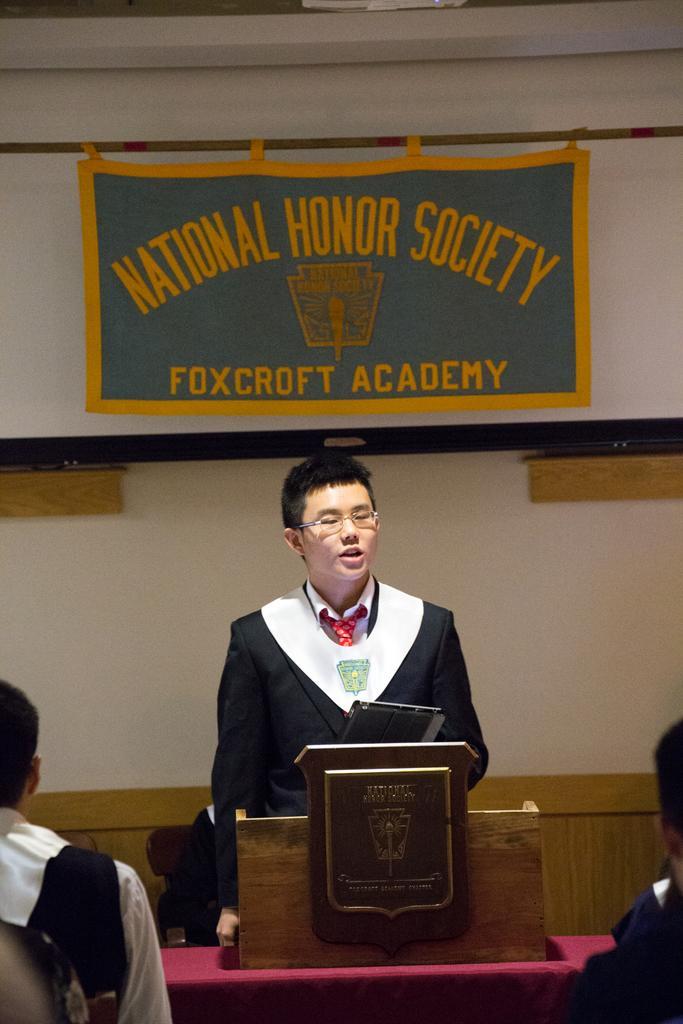Describe this image in one or two sentences. In the center of the image there is a person standing at the desk holding a tablet. In the background we can see banner and wall. At the bottom there are persons. 